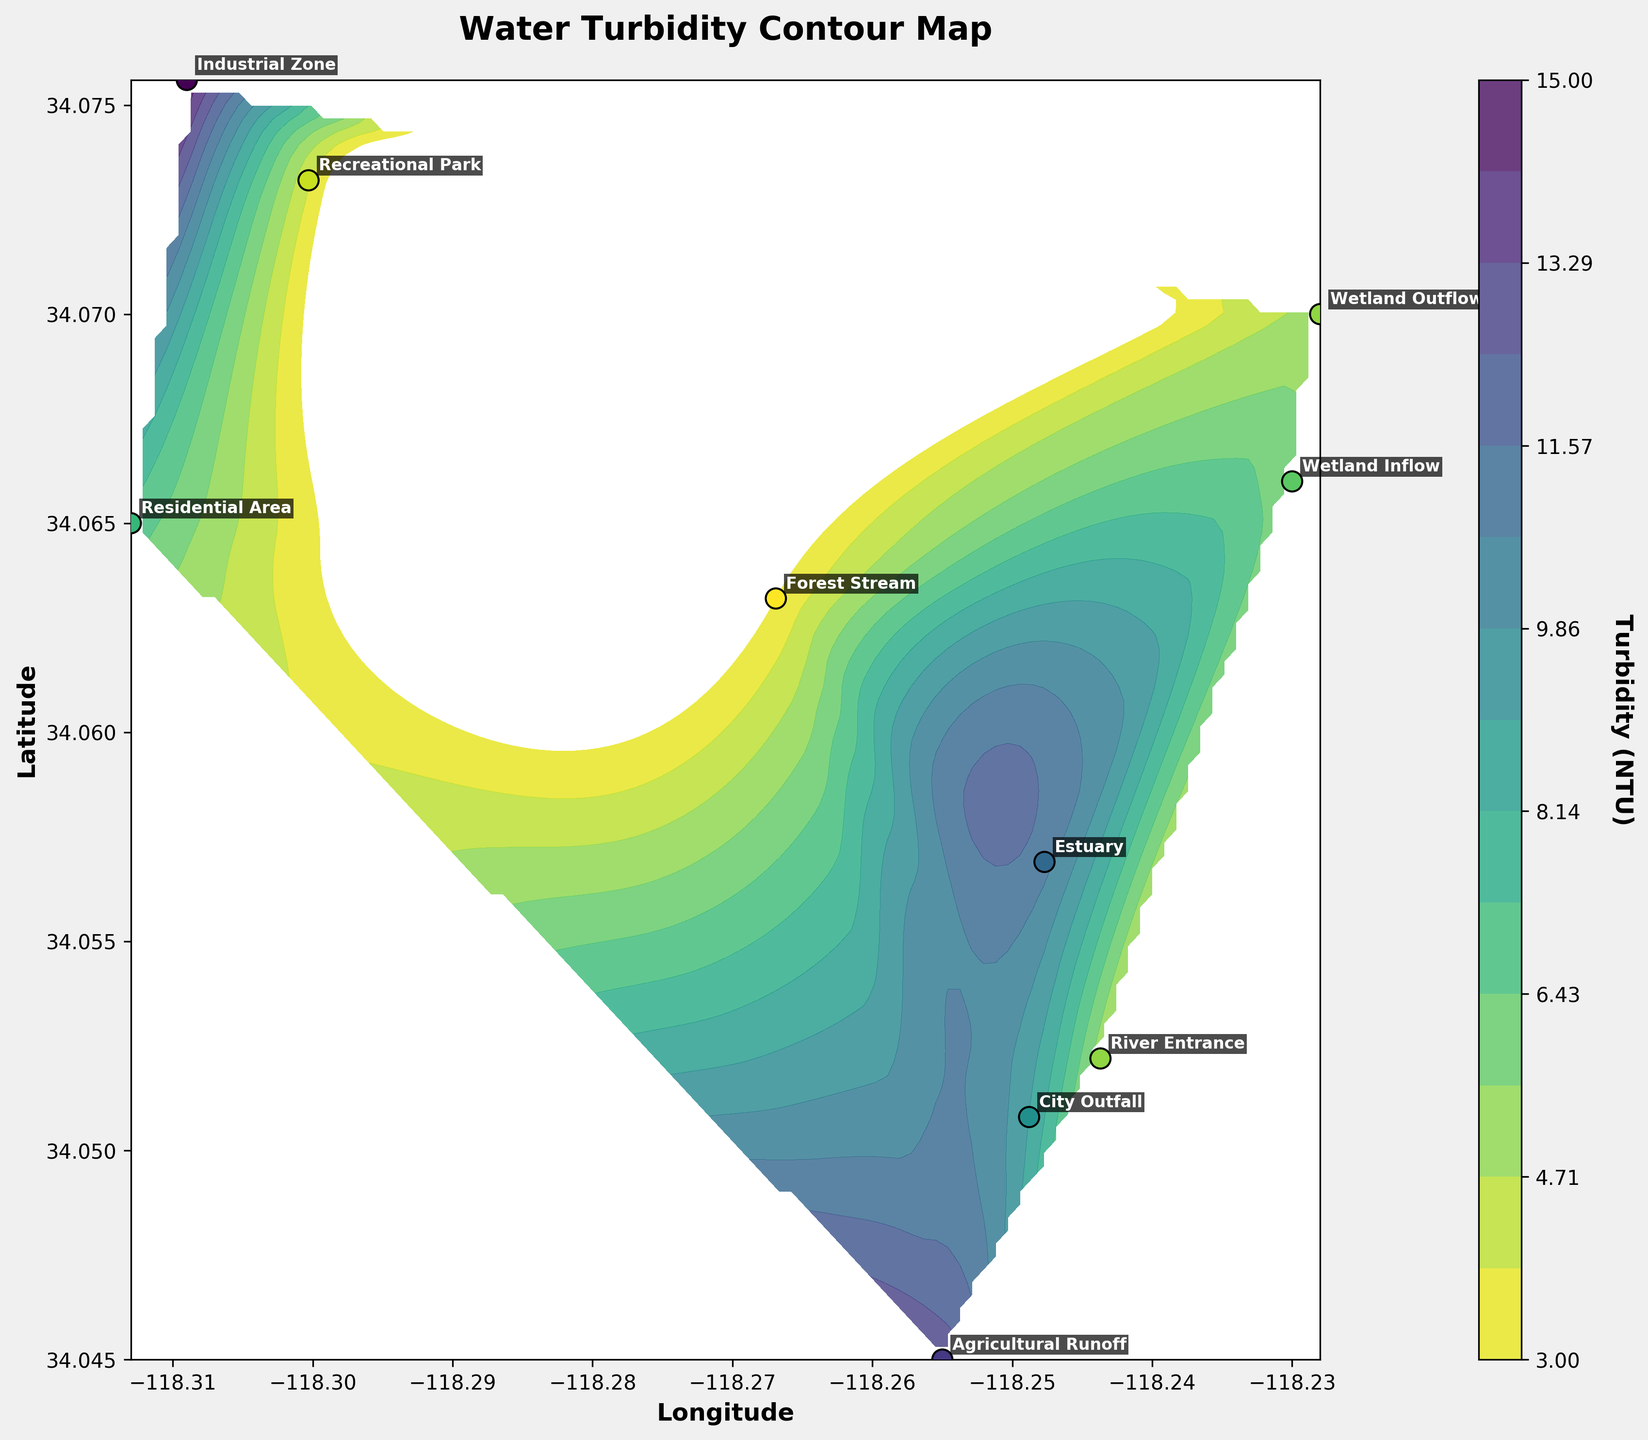What's the title of the plot? The title is displayed at the top of the plot. It summarizes the content of the plot regarding the turbidity of water.
Answer: Water Turbidity Contour Map How many data points are represented on the plot? Data points are marked by scattered points on the contour plot, each labeled with its location.
Answer: 10 Which location has the highest turbidity according to the plot? By observing the color intensity in the contour plot and noting the data points' values, the location with the darkest shade represents the highest turbidity.
Answer: Industrial Zone Which location has the lowest turbidity on the plot? Observing the data points and their colors, the one with the lightest shade represents the lowest turbidity.
Answer: Forest Stream What is the range of turbidity values depicted in the plot? By looking at the color bar next to the plot, the minimum and maximum values of turbidity can be identified.
Answer: 3 to 15 NTU Between the City Outfall and the Estuary, which one has a higher turbidity level? Comparing the colors of the data points for City Outfall and Estuary, the one with a darker color and higher value has higher turbidity.
Answer: Estuary What is the average turbidity value of the Agricultural Runoff and Recreational Park? Sum the turbidity values of Agricultural Runoff (13 NTU) and Recreational Park (4 NTU) and divide by 2 to find the average.
Answer: 8.5 NTU Which region shows a significant decrease in turbidity from its inflow to its outflow? Identifying the locations labeled "Wetland Inflow" and "Wetland Outflow" and comparing their turbidity values will show a decrease if the outflow is lower.
Answer: Wetland Inflow to Wetland Outflow How does the turbidity level of the Residential Area compare to the River Entrance? Find the colors and values for both locations and determine which one is higher.
Answer: Residential Area is higher than River Entrance What is the dominant color range in areas with the cleanest water sources? Observing the color map, the cleanest sources have the lightest shades, often shades of yellow or light green.
Answer: Yellow/Light Green 